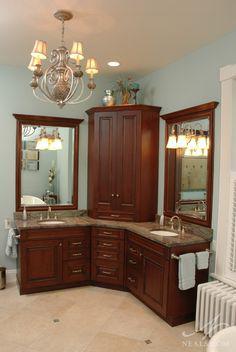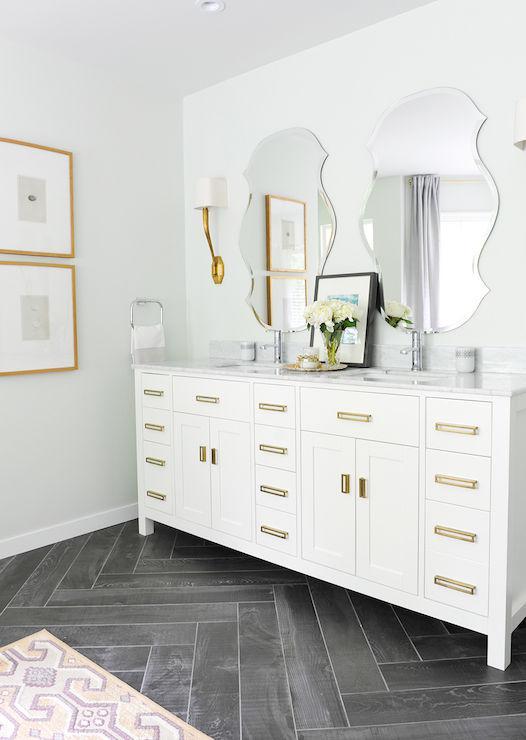The first image is the image on the left, the second image is the image on the right. For the images displayed, is the sentence "Both images have different wall colors and there is a stand alone bath tub in one of them." factually correct? Answer yes or no. No. 